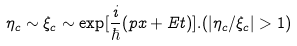<formula> <loc_0><loc_0><loc_500><loc_500>\eta _ { c } \sim \xi _ { c } \sim \exp [ \frac { i } { \hbar } { ( } p x + E t ) ] . ( \left | \eta _ { c } / \xi _ { c } \right | > 1 )</formula> 